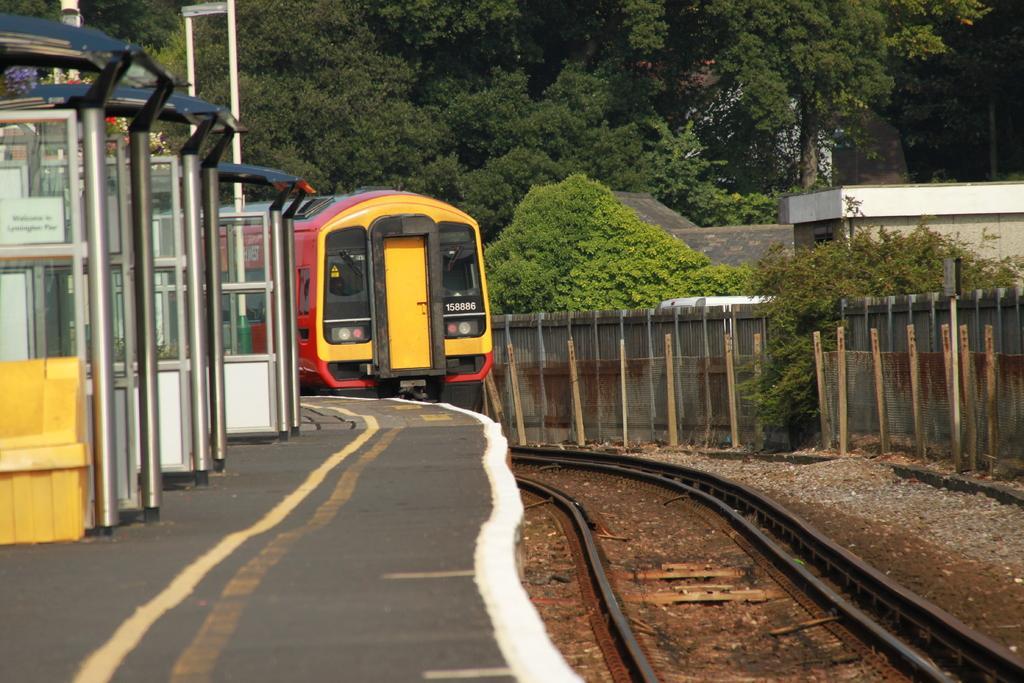In one or two sentences, can you explain what this image depicts? In this image we can see a train on the railway track, there is a fence, wall, few trees and a building on the right side and on the left side there are few objects looks like rooms on the platform. 